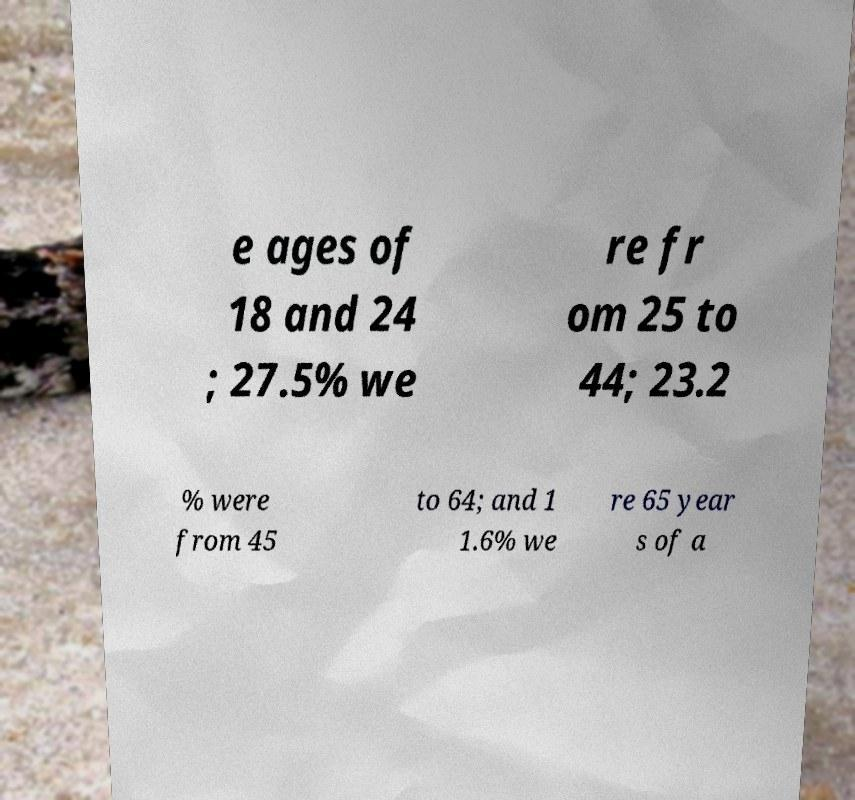Can you read and provide the text displayed in the image?This photo seems to have some interesting text. Can you extract and type it out for me? e ages of 18 and 24 ; 27.5% we re fr om 25 to 44; 23.2 % were from 45 to 64; and 1 1.6% we re 65 year s of a 